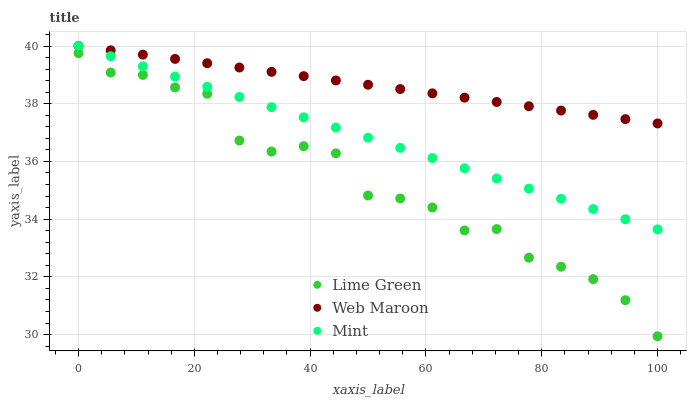Does Lime Green have the minimum area under the curve?
Answer yes or no. Yes. Does Web Maroon have the maximum area under the curve?
Answer yes or no. Yes. Does Mint have the minimum area under the curve?
Answer yes or no. No. Does Mint have the maximum area under the curve?
Answer yes or no. No. Is Web Maroon the smoothest?
Answer yes or no. Yes. Is Lime Green the roughest?
Answer yes or no. Yes. Is Mint the smoothest?
Answer yes or no. No. Is Mint the roughest?
Answer yes or no. No. Does Lime Green have the lowest value?
Answer yes or no. Yes. Does Mint have the lowest value?
Answer yes or no. No. Does Mint have the highest value?
Answer yes or no. Yes. Does Lime Green have the highest value?
Answer yes or no. No. Is Lime Green less than Web Maroon?
Answer yes or no. Yes. Is Web Maroon greater than Lime Green?
Answer yes or no. Yes. Does Web Maroon intersect Mint?
Answer yes or no. Yes. Is Web Maroon less than Mint?
Answer yes or no. No. Is Web Maroon greater than Mint?
Answer yes or no. No. Does Lime Green intersect Web Maroon?
Answer yes or no. No. 